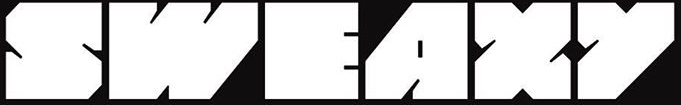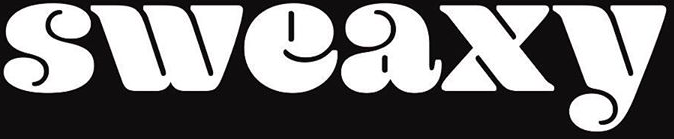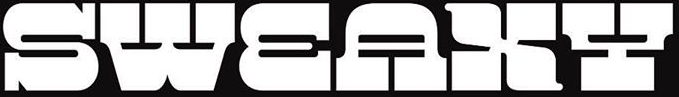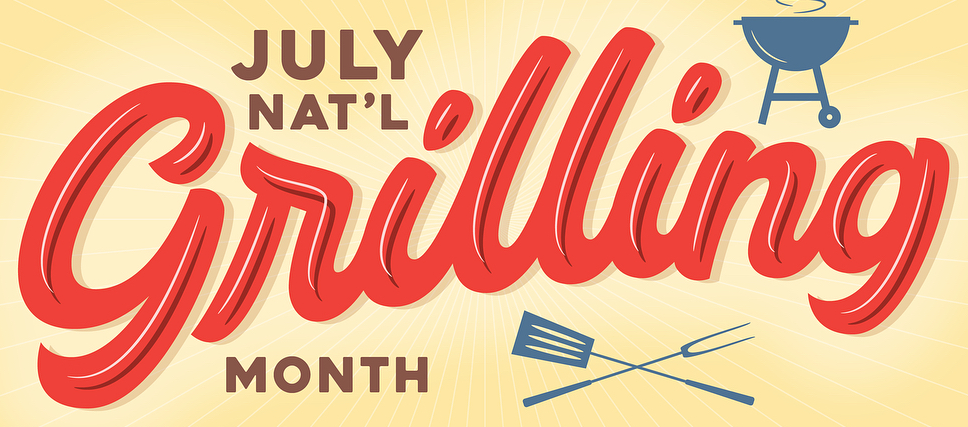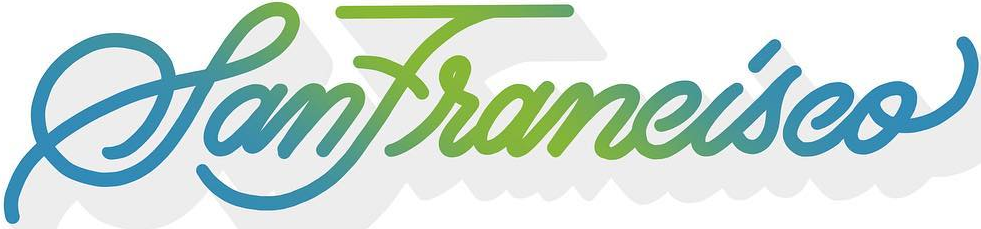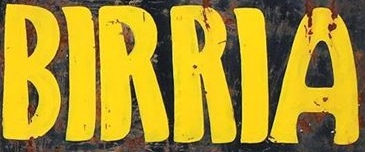Transcribe the words shown in these images in order, separated by a semicolon. SWEAXY; sweaxy; SWEAXY; Grilling; SanFrancisco; BIRRIA 